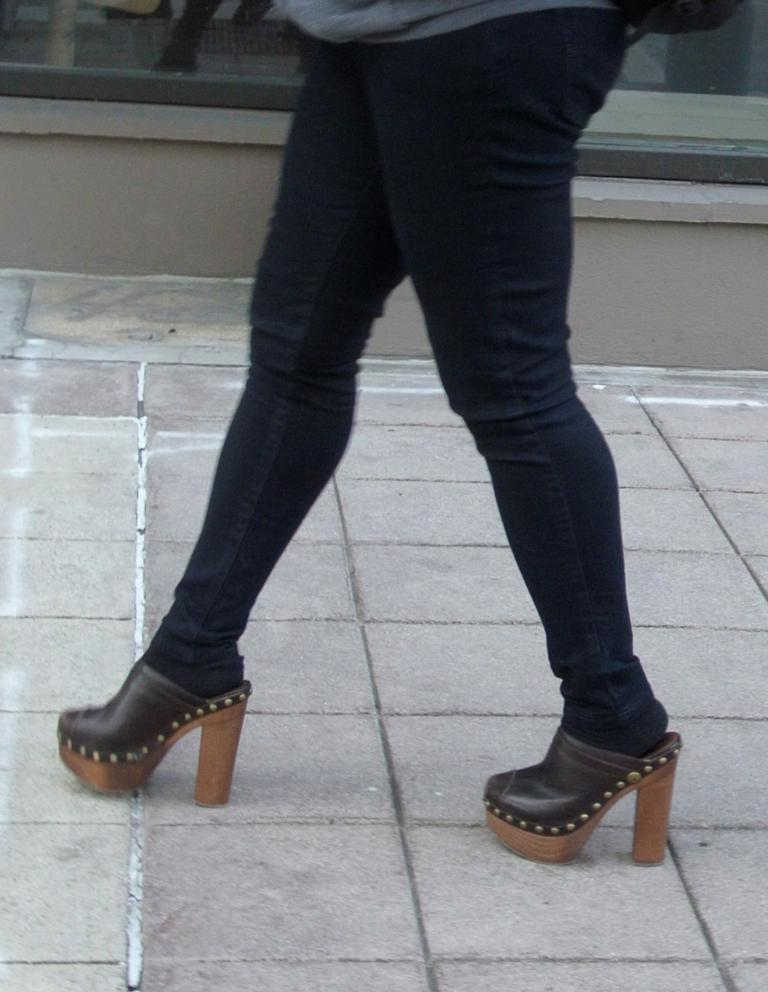Where was the image taken? The image is taken outdoors. What is visible at the bottom of the image? There is a floor at the bottom of the image. What can be seen in the background of the image? There is a wall in the background of the image. What is the woman in the image doing? A woman is walking in the middle of the image. What type of debt is the woman carrying in the image? There is no indication of debt in the image; it features a woman walking outdoors. Can you see any deer in the image? No, there are no deer present in the image. 